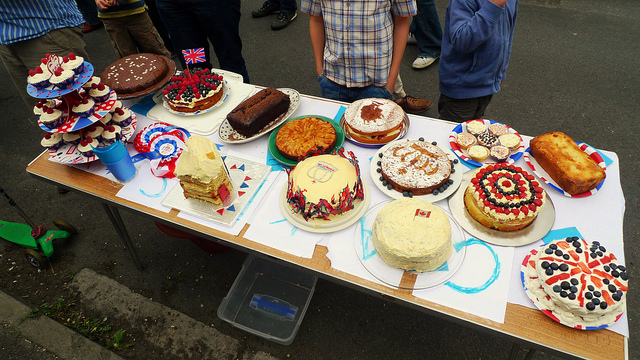<image>How are the cakes packed? It's unclear how the cakes are packed. They could be on plates or in individual packs. Is the person in the purple top male or female? I am not sure about the gender of the person in the purple top. It could be either male or female. What color is the star? It is ambiguous what color the star is. It could be gold, red, or red white and blue. Is the person in the purple top male or female? I am not sure if the person in the purple top is male or female. How are the cakes packed? The cakes are packed in different ways. They can be packed on plates, on cake trays, or individually. What color is the star? The star is red in color. 